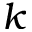Convert formula to latex. <formula><loc_0><loc_0><loc_500><loc_500>k</formula> 